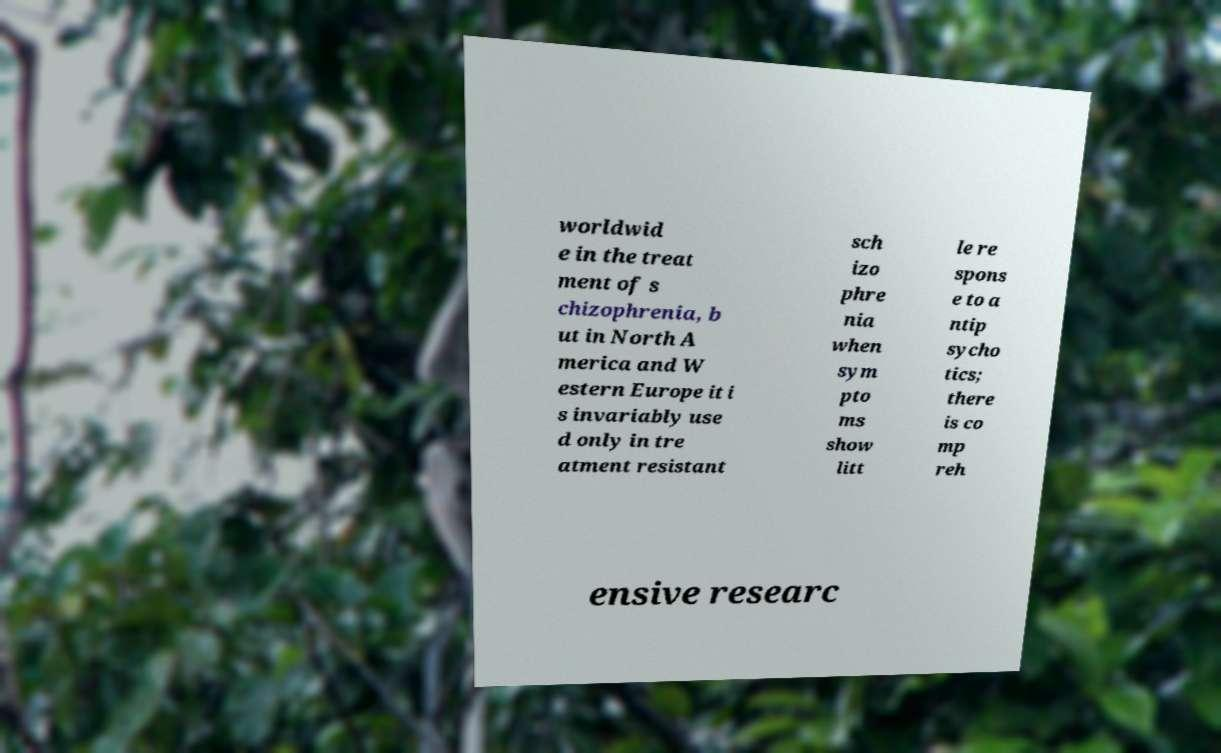For documentation purposes, I need the text within this image transcribed. Could you provide that? worldwid e in the treat ment of s chizophrenia, b ut in North A merica and W estern Europe it i s invariably use d only in tre atment resistant sch izo phre nia when sym pto ms show litt le re spons e to a ntip sycho tics; there is co mp reh ensive researc 